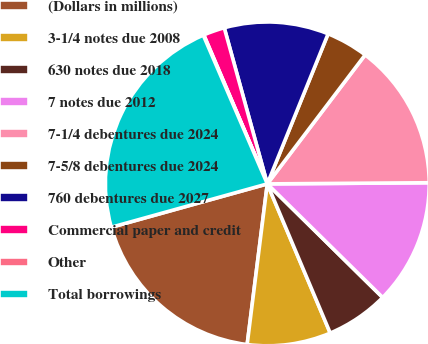Convert chart to OTSL. <chart><loc_0><loc_0><loc_500><loc_500><pie_chart><fcel>(Dollars in millions)<fcel>3-1/4 notes due 2008<fcel>630 notes due 2018<fcel>7 notes due 2012<fcel>7-1/4 debentures due 2024<fcel>7-5/8 debentures due 2024<fcel>760 debentures due 2027<fcel>Commercial paper and credit<fcel>Other<fcel>Total borrowings<nl><fcel>18.7%<fcel>8.34%<fcel>6.27%<fcel>12.49%<fcel>14.56%<fcel>4.2%<fcel>10.41%<fcel>2.13%<fcel>0.06%<fcel>22.84%<nl></chart> 